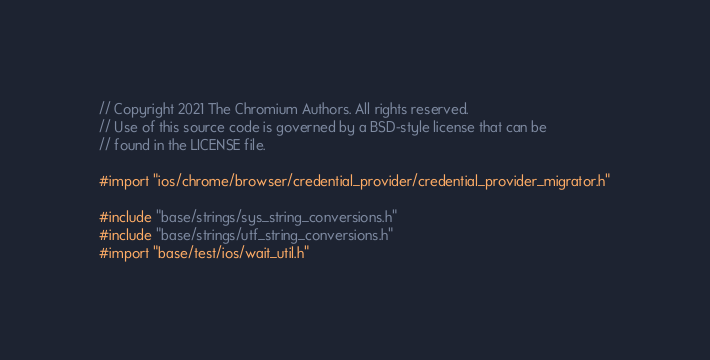<code> <loc_0><loc_0><loc_500><loc_500><_ObjectiveC_>// Copyright 2021 The Chromium Authors. All rights reserved.
// Use of this source code is governed by a BSD-style license that can be
// found in the LICENSE file.

#import "ios/chrome/browser/credential_provider/credential_provider_migrator.h"

#include "base/strings/sys_string_conversions.h"
#include "base/strings/utf_string_conversions.h"
#import "base/test/ios/wait_util.h"</code> 